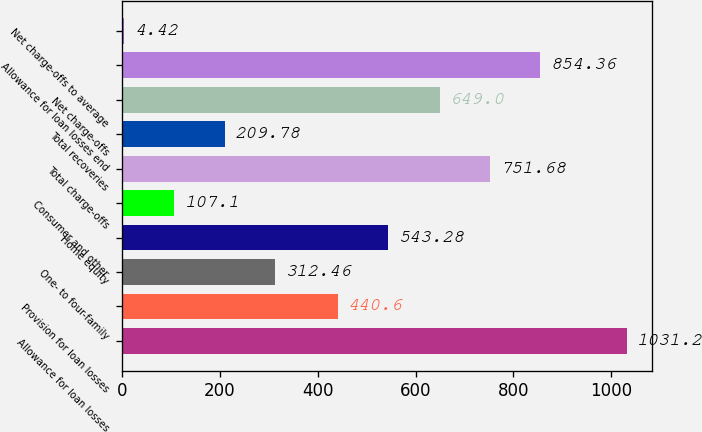Convert chart. <chart><loc_0><loc_0><loc_500><loc_500><bar_chart><fcel>Allowance for loan losses<fcel>Provision for loan losses<fcel>One- to four-family<fcel>Home equity<fcel>Consumer and other<fcel>Total charge-offs<fcel>Total recoveries<fcel>Net charge-offs<fcel>Allowance for loan losses end<fcel>Net charge-offs to average<nl><fcel>1031.2<fcel>440.6<fcel>312.46<fcel>543.28<fcel>107.1<fcel>751.68<fcel>209.78<fcel>649<fcel>854.36<fcel>4.42<nl></chart> 